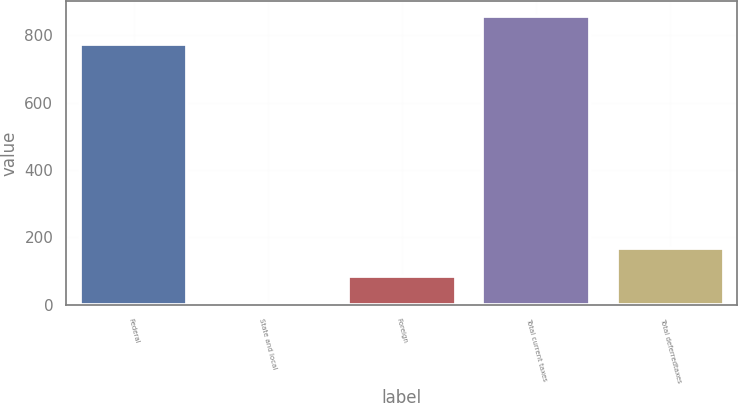Convert chart. <chart><loc_0><loc_0><loc_500><loc_500><bar_chart><fcel>Federal<fcel>State and local<fcel>Foreign<fcel>Total current taxes<fcel>Total deferredtaxes<nl><fcel>774.4<fcel>1<fcel>84.41<fcel>857.81<fcel>167.82<nl></chart> 